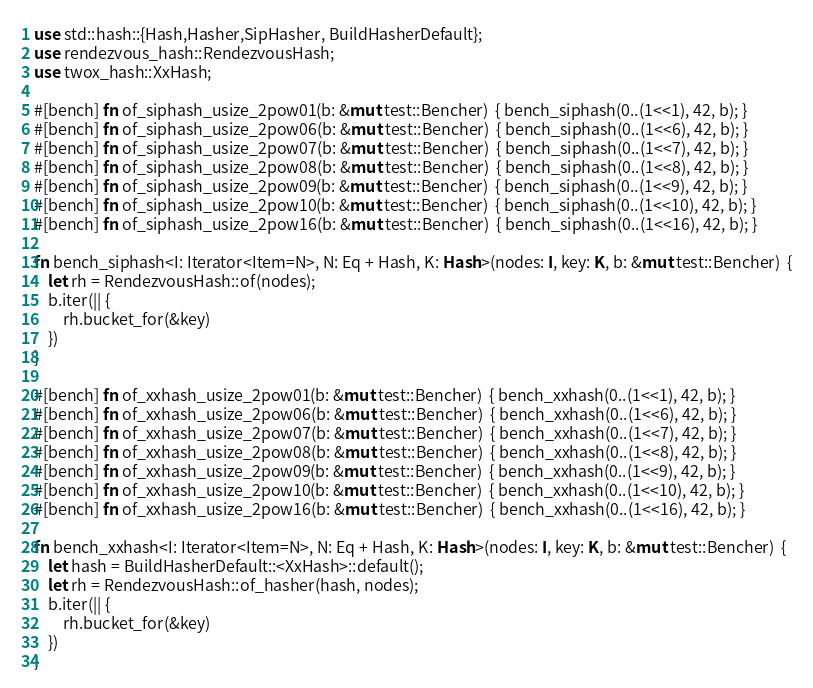<code> <loc_0><loc_0><loc_500><loc_500><_Rust_>
use std::hash::{Hash,Hasher,SipHasher, BuildHasherDefault};
use rendezvous_hash::RendezvousHash;
use twox_hash::XxHash;

#[bench] fn of_siphash_usize_2pow01(b: &mut test::Bencher)  { bench_siphash(0..(1<<1), 42, b); }
#[bench] fn of_siphash_usize_2pow06(b: &mut test::Bencher)  { bench_siphash(0..(1<<6), 42, b); }
#[bench] fn of_siphash_usize_2pow07(b: &mut test::Bencher)  { bench_siphash(0..(1<<7), 42, b); }
#[bench] fn of_siphash_usize_2pow08(b: &mut test::Bencher)  { bench_siphash(0..(1<<8), 42, b); }
#[bench] fn of_siphash_usize_2pow09(b: &mut test::Bencher)  { bench_siphash(0..(1<<9), 42, b); }
#[bench] fn of_siphash_usize_2pow10(b: &mut test::Bencher)  { bench_siphash(0..(1<<10), 42, b); }
#[bench] fn of_siphash_usize_2pow16(b: &mut test::Bencher)  { bench_siphash(0..(1<<16), 42, b); }

fn bench_siphash<I: Iterator<Item=N>, N: Eq + Hash, K: Hash>(nodes: I, key: K, b: &mut test::Bencher)  {
    let rh = RendezvousHash::of(nodes);
    b.iter(|| {
        rh.bucket_for(&key)
    })
}

#[bench] fn of_xxhash_usize_2pow01(b: &mut test::Bencher)  { bench_xxhash(0..(1<<1), 42, b); }
#[bench] fn of_xxhash_usize_2pow06(b: &mut test::Bencher)  { bench_xxhash(0..(1<<6), 42, b); }
#[bench] fn of_xxhash_usize_2pow07(b: &mut test::Bencher)  { bench_xxhash(0..(1<<7), 42, b); }
#[bench] fn of_xxhash_usize_2pow08(b: &mut test::Bencher)  { bench_xxhash(0..(1<<8), 42, b); }
#[bench] fn of_xxhash_usize_2pow09(b: &mut test::Bencher)  { bench_xxhash(0..(1<<9), 42, b); }
#[bench] fn of_xxhash_usize_2pow10(b: &mut test::Bencher)  { bench_xxhash(0..(1<<10), 42, b); }
#[bench] fn of_xxhash_usize_2pow16(b: &mut test::Bencher)  { bench_xxhash(0..(1<<16), 42, b); }

fn bench_xxhash<I: Iterator<Item=N>, N: Eq + Hash, K: Hash>(nodes: I, key: K, b: &mut test::Bencher)  {
    let hash = BuildHasherDefault::<XxHash>::default();
    let rh = RendezvousHash::of_hasher(hash, nodes);
    b.iter(|| {
        rh.bucket_for(&key)
    })
}
</code> 